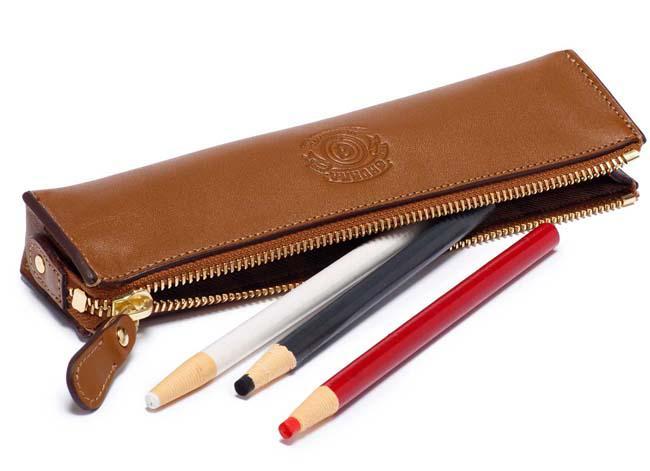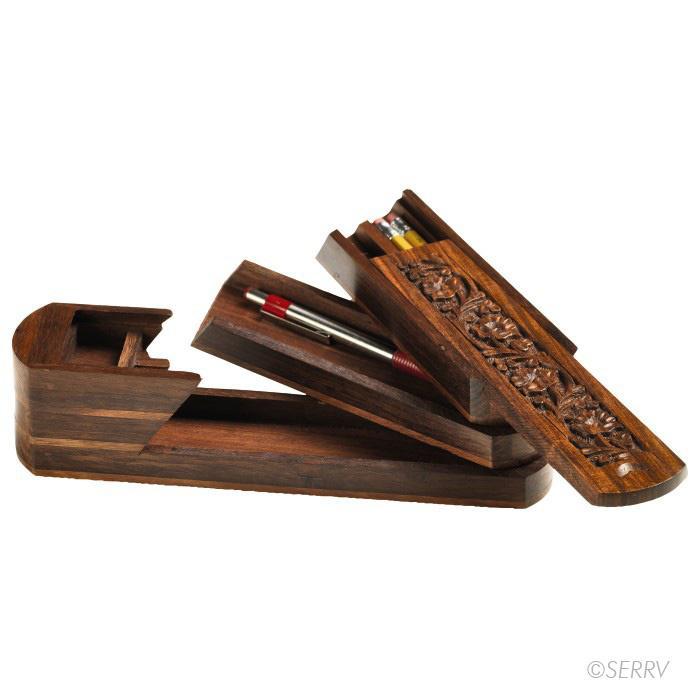The first image is the image on the left, the second image is the image on the right. Analyze the images presented: Is the assertion "An image features a wooden pencil box that slides open, revealing several colored-lead pencils insides." valid? Answer yes or no. No. The first image is the image on the left, the second image is the image on the right. Analyze the images presented: Is the assertion "The sliding top of a wooden pencil box is opened to display two levels of storage with an end space to store a sharpener, while a leather pencil case is shown in a second image." valid? Answer yes or no. Yes. 